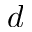Convert formula to latex. <formula><loc_0><loc_0><loc_500><loc_500>d</formula> 